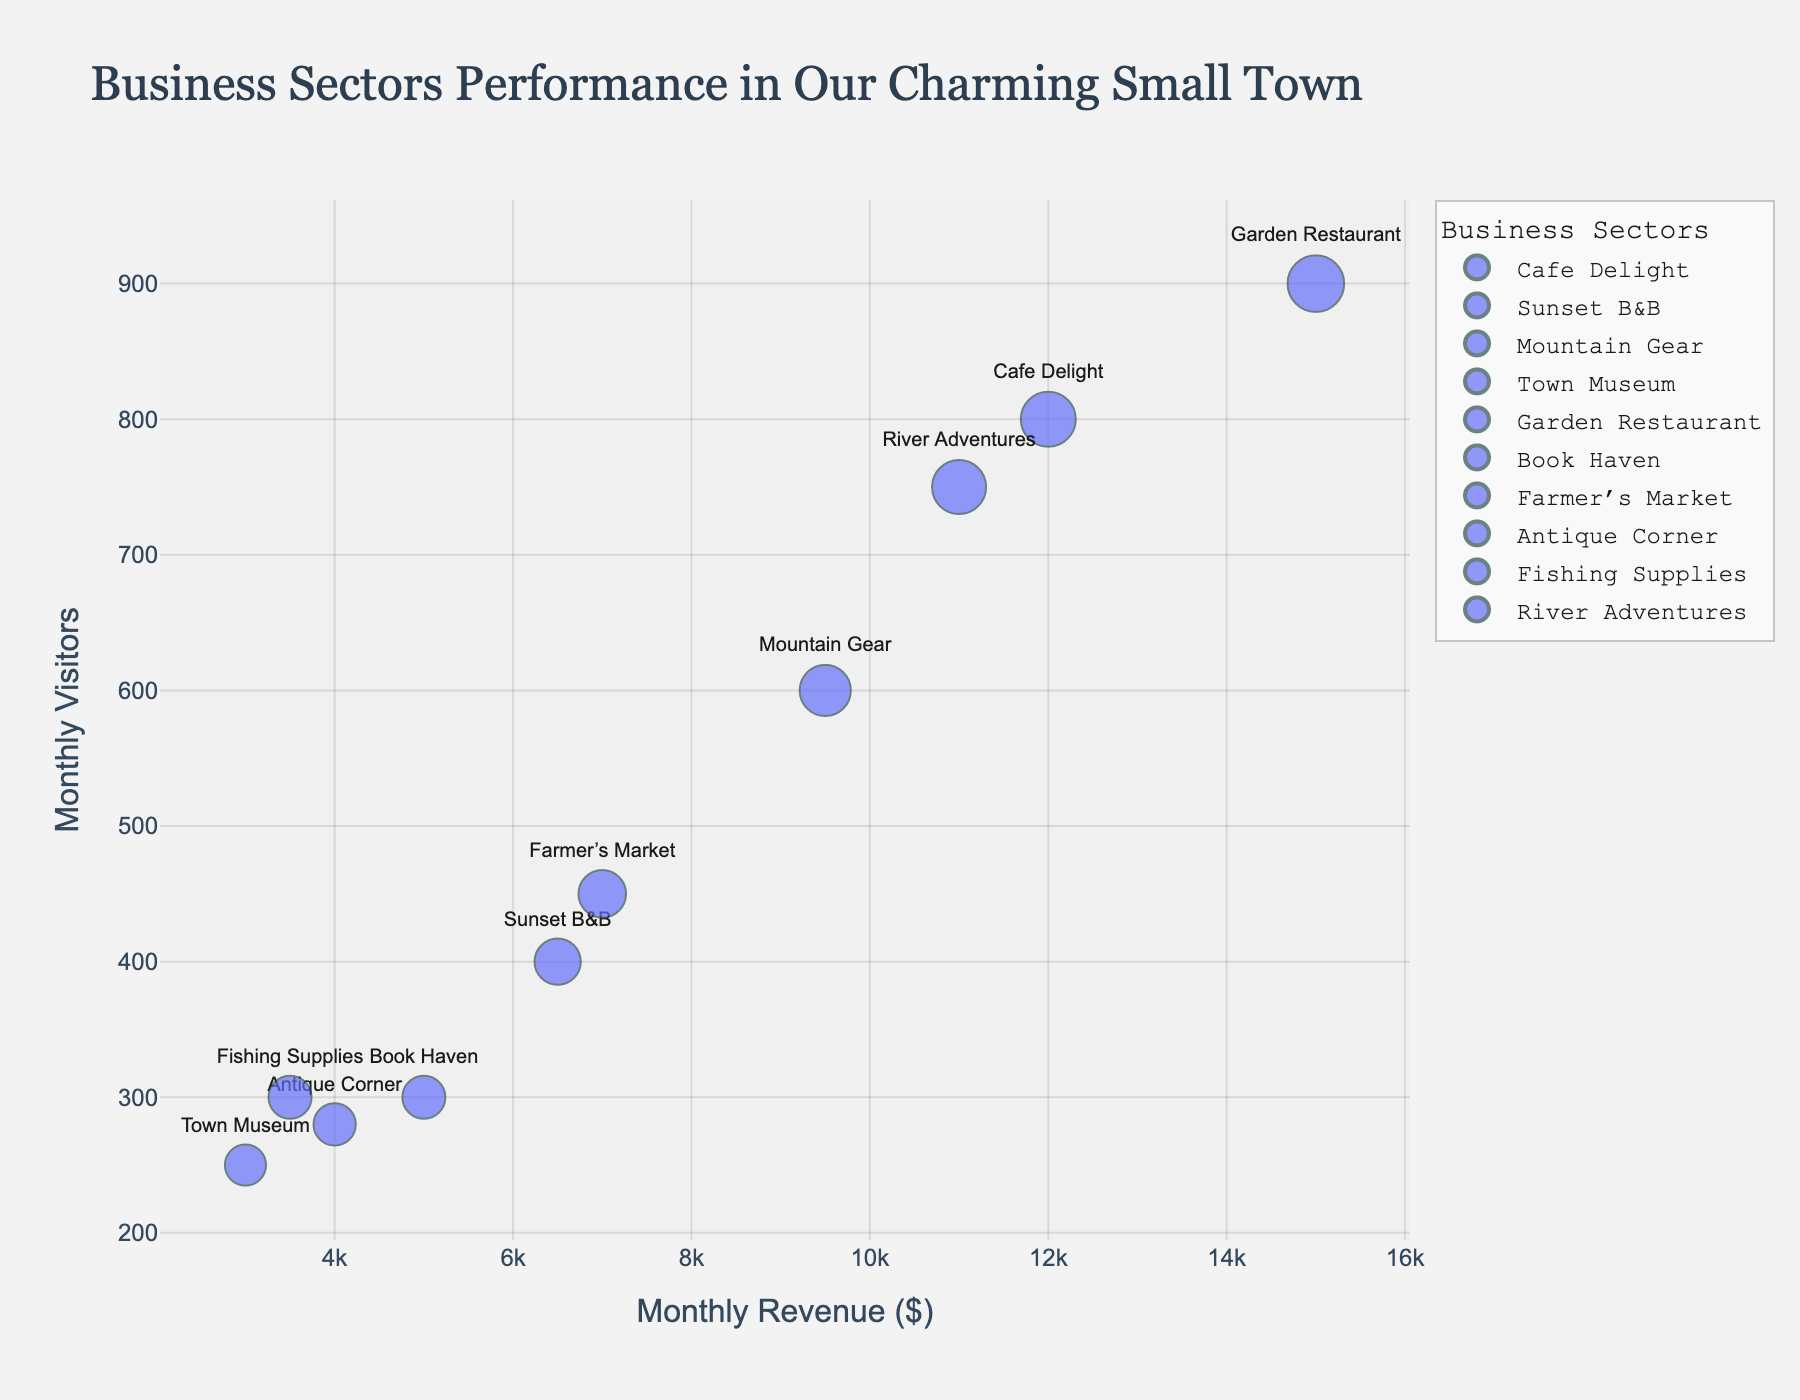Which business sector has the highest monthly revenue? The highest monthly revenue can be identified by looking at the revenue axis and finding the sector with the topmost bubble. “Garden Restaurant” has the highest monthly revenue.
Answer: Garden Restaurant What is the monthly visitor count for Cafe Delight? To find the monthly visitor count for Cafe Delight, locate its bubble and refer to the position on the visitor count axis. The value for Cafe Delight is 800.
Answer: 800 How does the monthly revenue of River Adventures compare to that of Mountain Gear? To compare the monthly revenue, locate the bubbles for both sectors on the revenue axis. River Adventures has a higher monthly revenue than Mountain Gear ($11,000 vs $9,500).
Answer: Higher Which business sectors have fewer than 500 monthly visitors? To identify sectors with fewer than 500 visitors, find the bubbles positioned below the 500-mark on the visitor count axis. These sectors are Sunset B&B, Town Museum, Book Haven, Antique Corner, and Fishing Supplies.
Answer: Sunset B&B, Town Museum, Book Haven, Antique Corner, Fishing Supplies What is the average monthly revenue of businesses with more than 600 visitors? First, identify sectors with more than 600 visitors (Cafe Delight, Garden Restaurant, River Adventures). The revenues are $12,000, $15,000, $11,000, respectively. Calculate the average: (12,000 + 15,000 + 11,000) / 3 = 12,667.
Answer: 12,667 Which business sector has the largest bubble in the chart? The largest bubble indicates the highest number of visitors. By examining the bubble sizes, "Garden Restaurant" is the largest.
Answer: Garden Restaurant Is there a sector with low revenue but high visitors? Identify sectors where the bubble is high on the visitor count axis but the position is low on the revenue axis. There are no sectors with this exact combination; higher visitors generally correlate with higher revenue.
Answer: No Compare the visitor count of Farmer’s Market to that of Antique Corner. Compare the position of Farmer’s Market and Antique Corner on the visitor count axis. Farmer’s Market has 450 visitors, and Antique Corner has 280 visitors, so Farmer’s Market has more visitors.
Answer: Farmer’s Market Which businesses have a revenue between $5000 and $10000? Identify bubbles whose position on the revenue axis lies between $5000 and $10000. These businesses are Mountain Gear, Book Haven, and Farmer’s Market.
Answer: Mountain Gear, Book Haven, Farmer’s Market What is the combined visitor count of businesses with revenue above $10000? First, identify businesses with revenue above $10000 (Cafe Delight, Garden Restaurant, River Adventures). The visitor counts are 800, 900, 750, respectively. Sum these counts: 800 + 900 + 750 = 2450.
Answer: 2450 